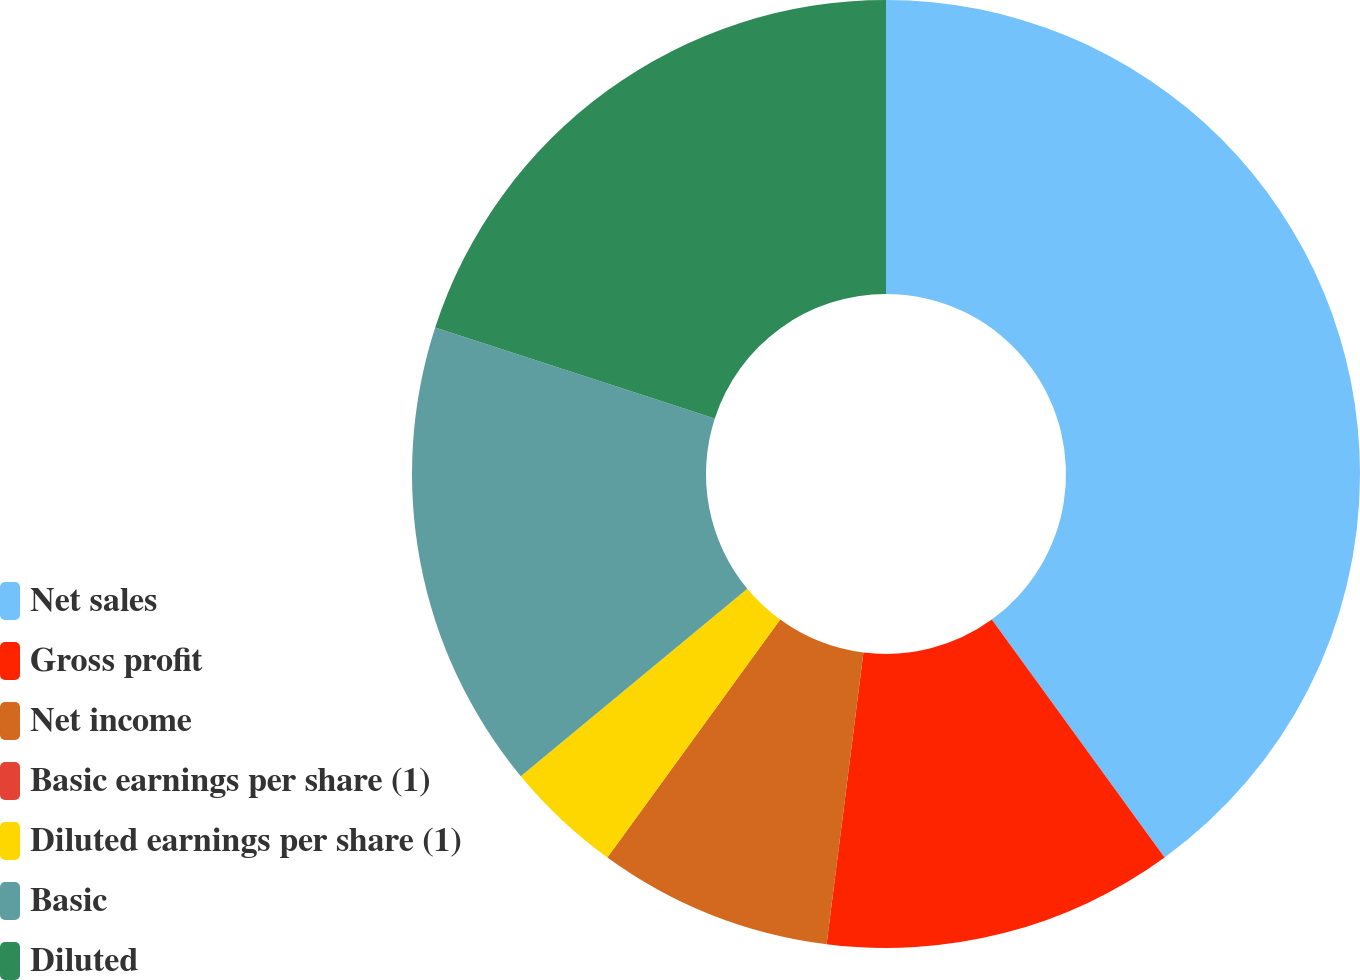<chart> <loc_0><loc_0><loc_500><loc_500><pie_chart><fcel>Net sales<fcel>Gross profit<fcel>Net income<fcel>Basic earnings per share (1)<fcel>Diluted earnings per share (1)<fcel>Basic<fcel>Diluted<nl><fcel>40.0%<fcel>12.0%<fcel>8.0%<fcel>0.0%<fcel>4.0%<fcel>16.0%<fcel>20.0%<nl></chart> 